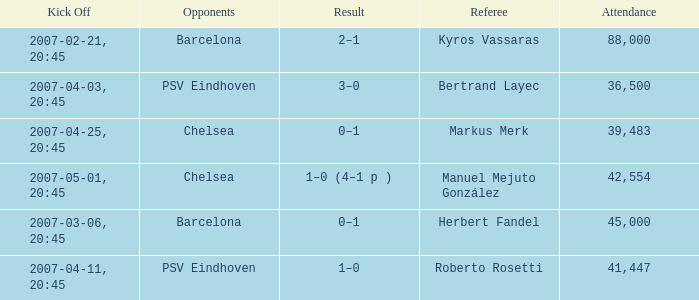WHAT WAS THE SCORE OF THE GAME WITH A 2007-03-06, 20:45 KICKOFF? 0–1. 